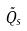<formula> <loc_0><loc_0><loc_500><loc_500>\tilde { Q _ { s } }</formula> 